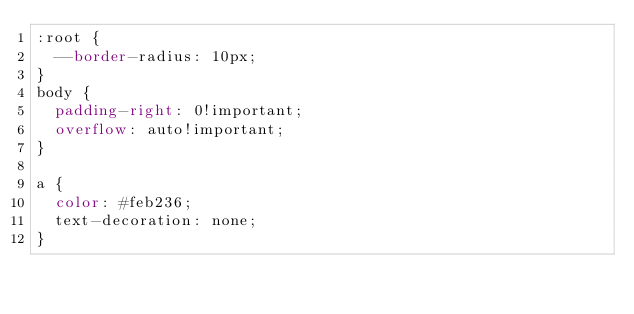<code> <loc_0><loc_0><loc_500><loc_500><_CSS_>:root {
  --border-radius: 10px;
}
body {
  padding-right: 0!important;
  overflow: auto!important;
}

a {
  color: #feb236;
  text-decoration: none;
}
</code> 